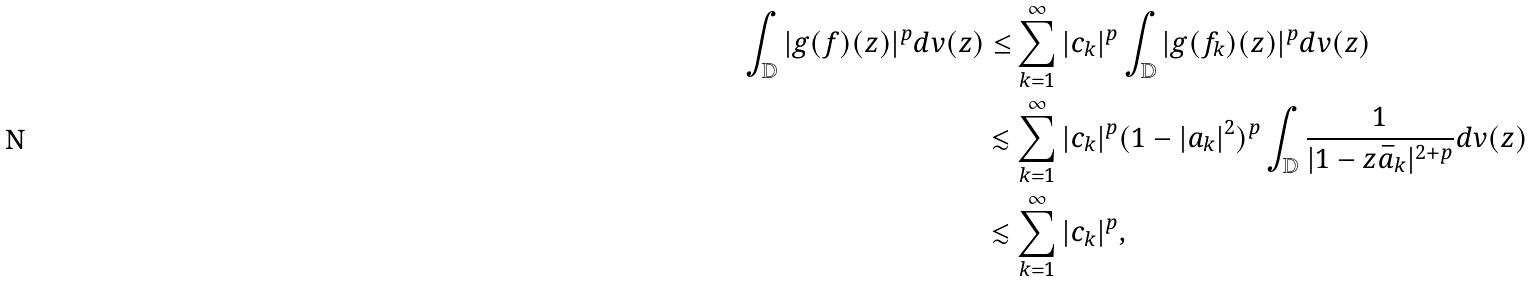<formula> <loc_0><loc_0><loc_500><loc_500>\int _ { \mathbb { D } } | g ( f ) ( z ) | ^ { p } d v ( z ) \leq & \sum _ { k = 1 } ^ { \infty } | c _ { k } | ^ { p } \int _ { \mathbb { D } } | g ( f _ { k } ) ( z ) | ^ { p } d v ( z ) \\ \lesssim & \sum _ { k = 1 } ^ { \infty } | c _ { k } | ^ { p } ( 1 - | a _ { k } | ^ { 2 } ) ^ { p } \int _ { \mathbb { D } } \frac { 1 } { | 1 - z \bar { a } _ { k } | ^ { 2 + p } } d v ( z ) \\ \lesssim & \sum _ { k = 1 } ^ { \infty } | c _ { k } | ^ { p } ,</formula> 